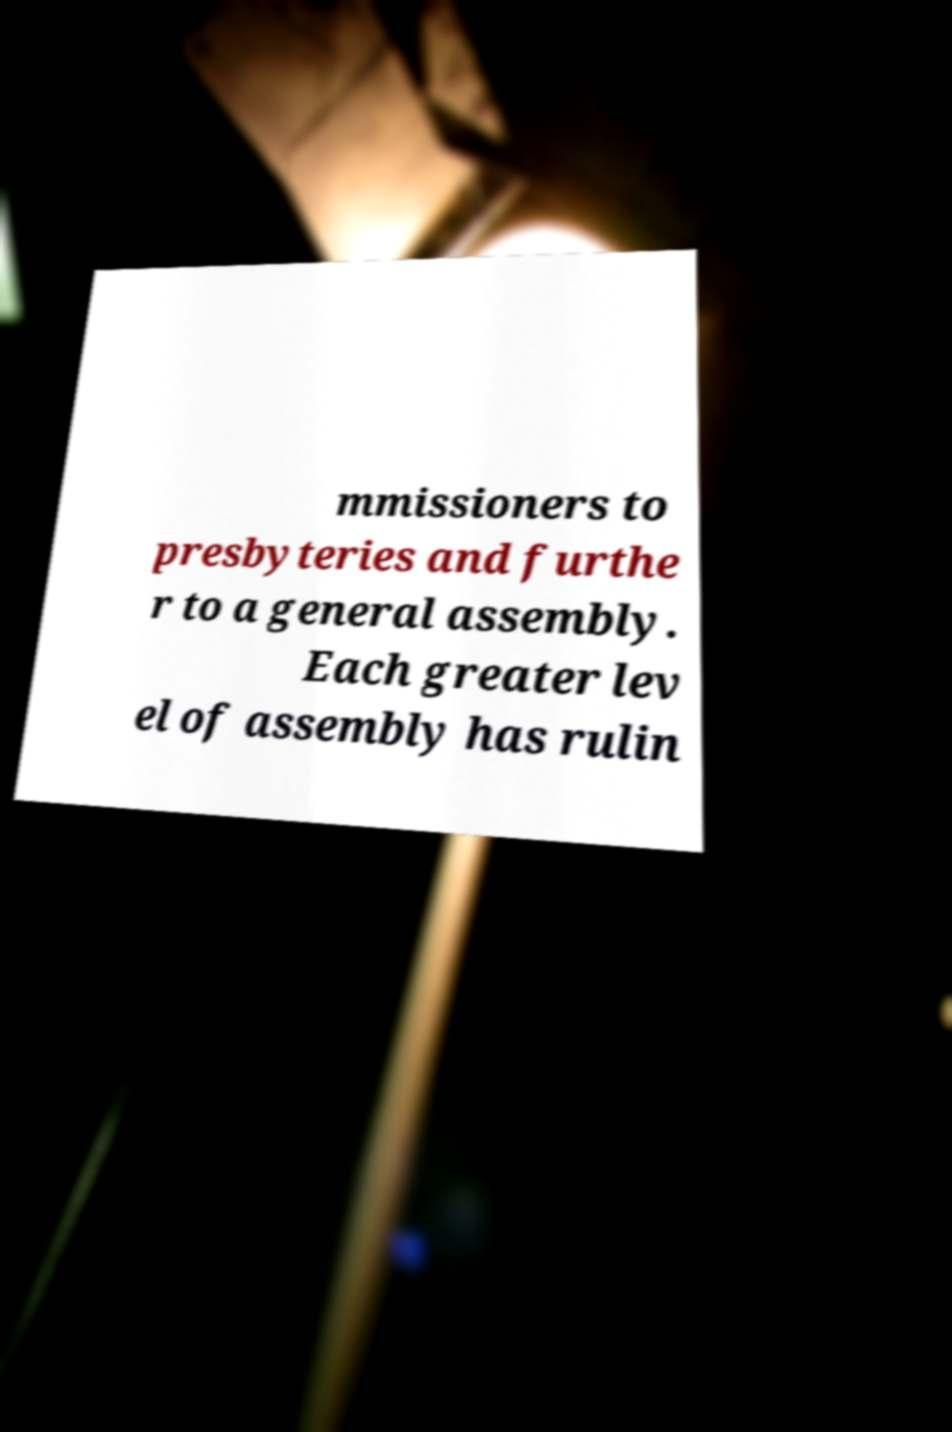For documentation purposes, I need the text within this image transcribed. Could you provide that? mmissioners to presbyteries and furthe r to a general assembly. Each greater lev el of assembly has rulin 